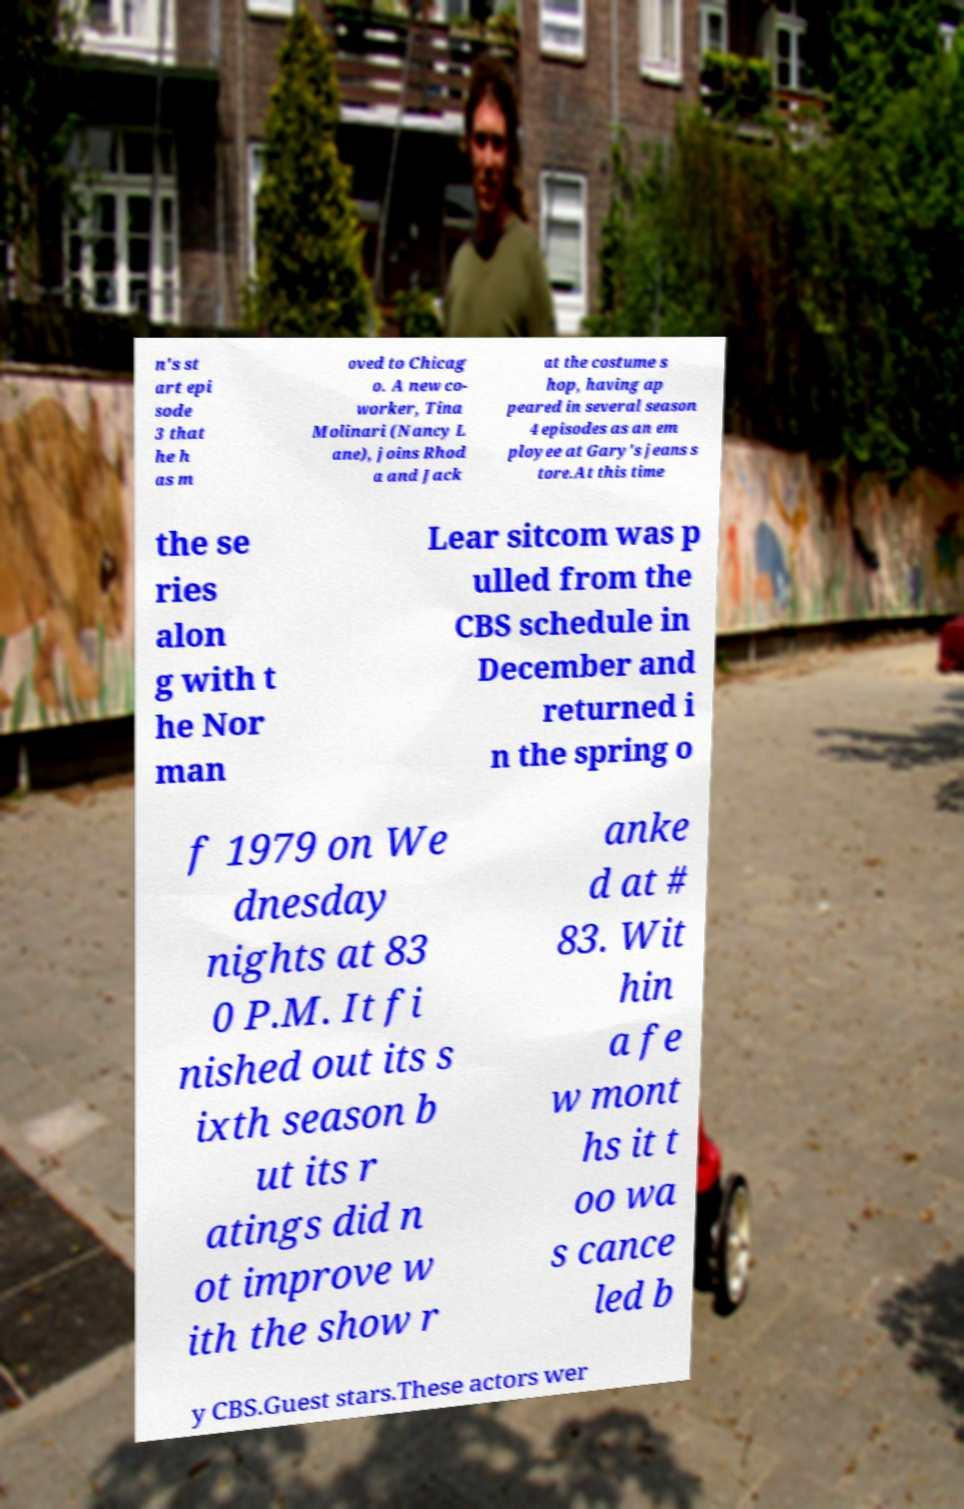What messages or text are displayed in this image? I need them in a readable, typed format. n's st art epi sode 3 that he h as m oved to Chicag o. A new co- worker, Tina Molinari (Nancy L ane), joins Rhod a and Jack at the costume s hop, having ap peared in several season 4 episodes as an em ployee at Gary's jeans s tore.At this time the se ries alon g with t he Nor man Lear sitcom was p ulled from the CBS schedule in December and returned i n the spring o f 1979 on We dnesday nights at 83 0 P.M. It fi nished out its s ixth season b ut its r atings did n ot improve w ith the show r anke d at # 83. Wit hin a fe w mont hs it t oo wa s cance led b y CBS.Guest stars.These actors wer 